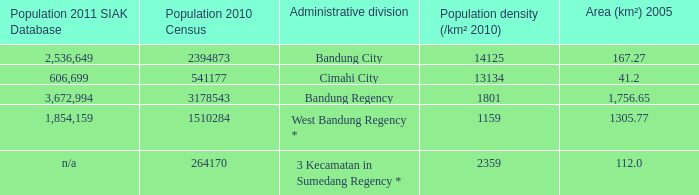What is the population density of the administrative division with a population in 2010 of 264170 according to the census? 2359.0. 